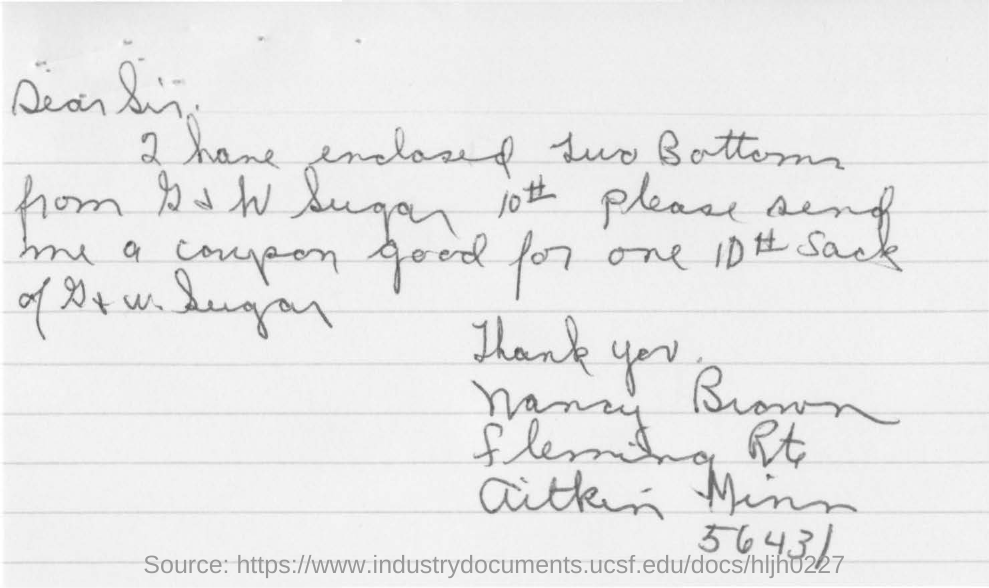Draw attention to some important aspects in this diagram. The ZIP code is 56431. 